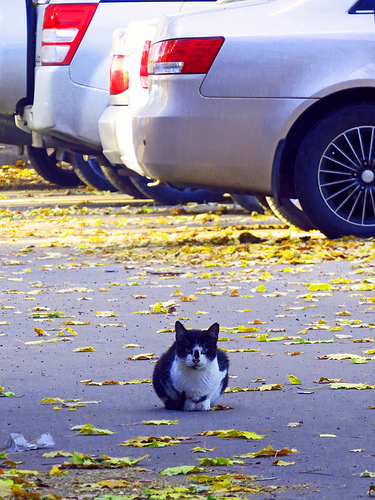<image>
Can you confirm if the cat is in front of the car? Yes. The cat is positioned in front of the car, appearing closer to the camera viewpoint. 